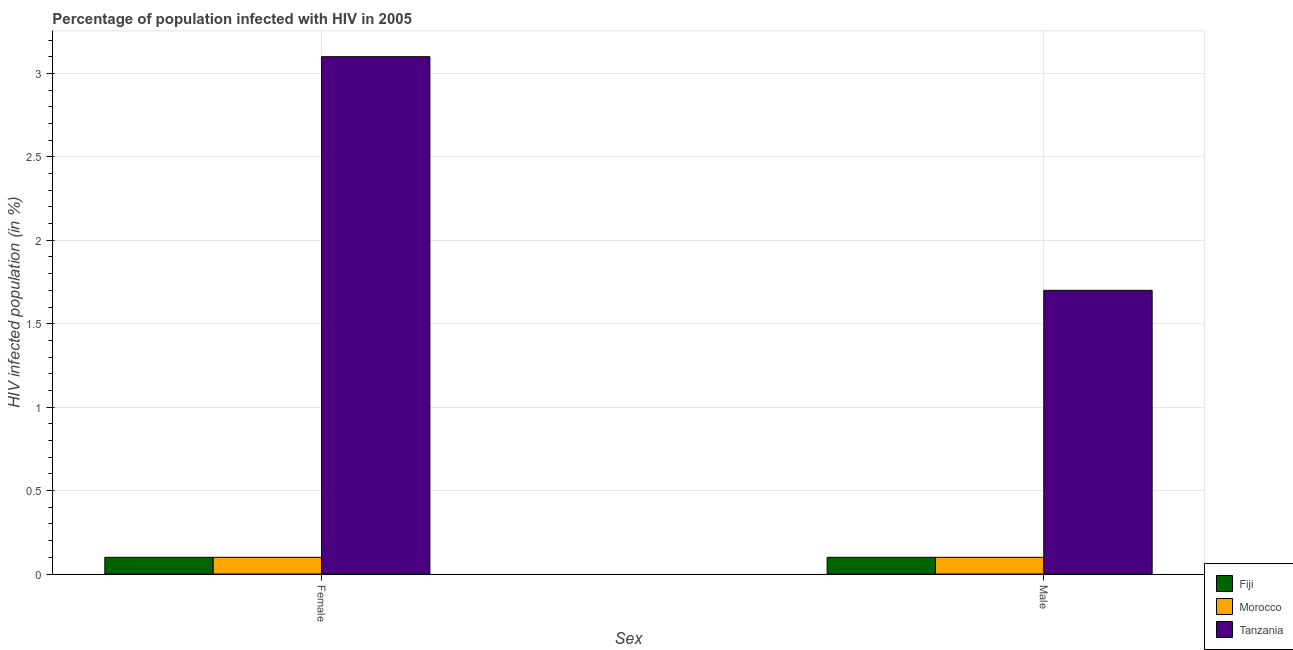How many different coloured bars are there?
Your answer should be compact. 3. How many groups of bars are there?
Provide a succinct answer. 2. Are the number of bars per tick equal to the number of legend labels?
Keep it short and to the point. Yes. Are the number of bars on each tick of the X-axis equal?
Give a very brief answer. Yes. How many bars are there on the 2nd tick from the left?
Provide a succinct answer. 3. What is the percentage of females who are infected with hiv in Tanzania?
Keep it short and to the point. 3.1. Across all countries, what is the minimum percentage of males who are infected with hiv?
Offer a very short reply. 0.1. In which country was the percentage of females who are infected with hiv maximum?
Make the answer very short. Tanzania. In which country was the percentage of males who are infected with hiv minimum?
Make the answer very short. Fiji. What is the total percentage of males who are infected with hiv in the graph?
Your answer should be compact. 1.9. What is the difference between the percentage of females who are infected with hiv in Tanzania and the percentage of males who are infected with hiv in Morocco?
Your response must be concise. 3. What is the difference between the percentage of males who are infected with hiv and percentage of females who are infected with hiv in Tanzania?
Give a very brief answer. -1.4. What is the ratio of the percentage of females who are infected with hiv in Tanzania to that in Morocco?
Your answer should be compact. 31. What does the 3rd bar from the left in Male represents?
Make the answer very short. Tanzania. What does the 3rd bar from the right in Female represents?
Make the answer very short. Fiji. How many bars are there?
Your response must be concise. 6. What is the difference between two consecutive major ticks on the Y-axis?
Give a very brief answer. 0.5. Are the values on the major ticks of Y-axis written in scientific E-notation?
Give a very brief answer. No. Does the graph contain grids?
Provide a succinct answer. Yes. Where does the legend appear in the graph?
Offer a terse response. Bottom right. How are the legend labels stacked?
Your answer should be compact. Vertical. What is the title of the graph?
Provide a succinct answer. Percentage of population infected with HIV in 2005. What is the label or title of the X-axis?
Ensure brevity in your answer.  Sex. What is the label or title of the Y-axis?
Make the answer very short. HIV infected population (in %). What is the HIV infected population (in %) in Fiji in Female?
Ensure brevity in your answer.  0.1. What is the HIV infected population (in %) of Morocco in Female?
Ensure brevity in your answer.  0.1. What is the HIV infected population (in %) of Tanzania in Female?
Make the answer very short. 3.1. What is the HIV infected population (in %) in Fiji in Male?
Offer a terse response. 0.1. What is the HIV infected population (in %) of Morocco in Male?
Your response must be concise. 0.1. What is the HIV infected population (in %) of Tanzania in Male?
Provide a succinct answer. 1.7. Across all Sex, what is the maximum HIV infected population (in %) of Fiji?
Keep it short and to the point. 0.1. Across all Sex, what is the maximum HIV infected population (in %) of Morocco?
Give a very brief answer. 0.1. Across all Sex, what is the maximum HIV infected population (in %) of Tanzania?
Make the answer very short. 3.1. Across all Sex, what is the minimum HIV infected population (in %) in Fiji?
Give a very brief answer. 0.1. Across all Sex, what is the minimum HIV infected population (in %) of Morocco?
Provide a succinct answer. 0.1. What is the total HIV infected population (in %) in Fiji in the graph?
Ensure brevity in your answer.  0.2. What is the total HIV infected population (in %) in Morocco in the graph?
Provide a short and direct response. 0.2. What is the total HIV infected population (in %) in Tanzania in the graph?
Give a very brief answer. 4.8. What is the difference between the HIV infected population (in %) of Fiji in Female and that in Male?
Your answer should be very brief. 0. What is the difference between the HIV infected population (in %) of Tanzania in Female and that in Male?
Make the answer very short. 1.4. What is the difference between the HIV infected population (in %) in Morocco in Female and the HIV infected population (in %) in Tanzania in Male?
Provide a short and direct response. -1.6. What is the average HIV infected population (in %) in Fiji per Sex?
Your response must be concise. 0.1. What is the difference between the HIV infected population (in %) in Fiji and HIV infected population (in %) in Tanzania in Female?
Keep it short and to the point. -3. What is the ratio of the HIV infected population (in %) of Fiji in Female to that in Male?
Provide a succinct answer. 1. What is the ratio of the HIV infected population (in %) in Morocco in Female to that in Male?
Ensure brevity in your answer.  1. What is the ratio of the HIV infected population (in %) of Tanzania in Female to that in Male?
Offer a terse response. 1.82. What is the difference between the highest and the second highest HIV infected population (in %) in Morocco?
Provide a short and direct response. 0. What is the difference between the highest and the second highest HIV infected population (in %) of Tanzania?
Give a very brief answer. 1.4. What is the difference between the highest and the lowest HIV infected population (in %) of Morocco?
Ensure brevity in your answer.  0. 